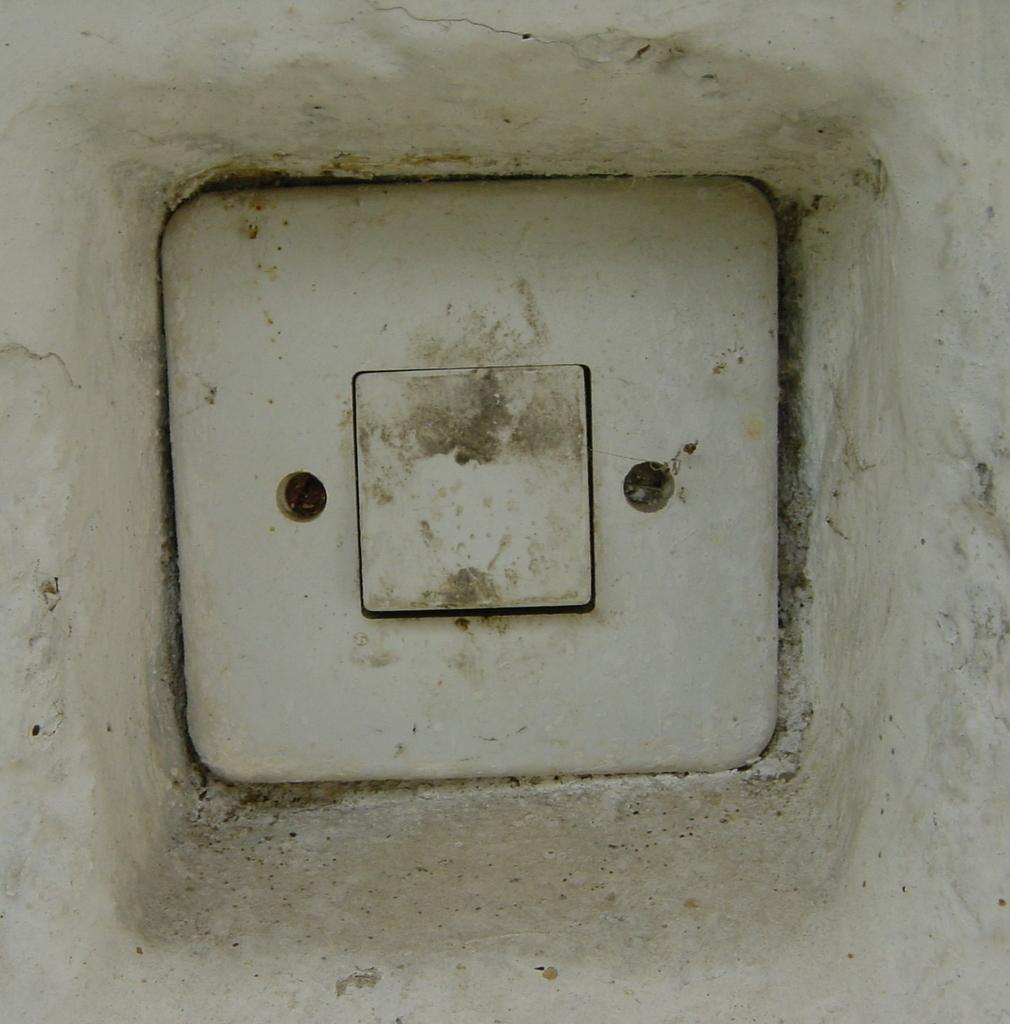What is the main object in the middle of the image? There is a switch in the middle of the image. Are there any other objects near the switch? Yes, there are two screws beside the switch. What type of vegetable is hidden behind the switch in the image? There is no vegetable present in the image; it only features a switch and two screws. 